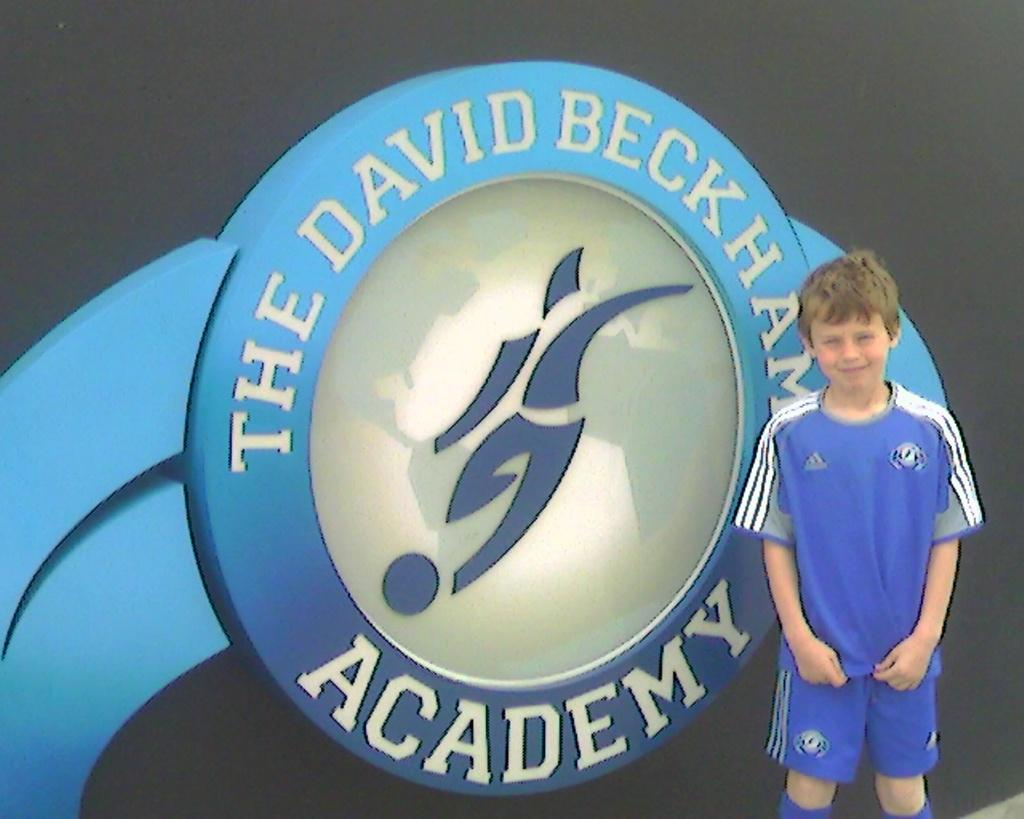<image>
Provide a brief description of the given image. A young boy stands next to the logo for the David Beckham Academy. 